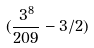<formula> <loc_0><loc_0><loc_500><loc_500>( \frac { 3 ^ { 8 } } { 2 0 9 } - 3 / 2 )</formula> 